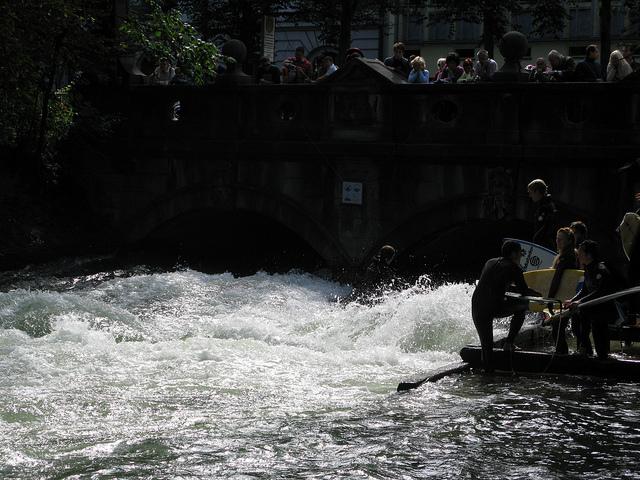Is the river dangerous?
Give a very brief answer. Yes. Is this outdoors?
Answer briefly. Yes. What are the people watching?
Be succinct. Surfers. 